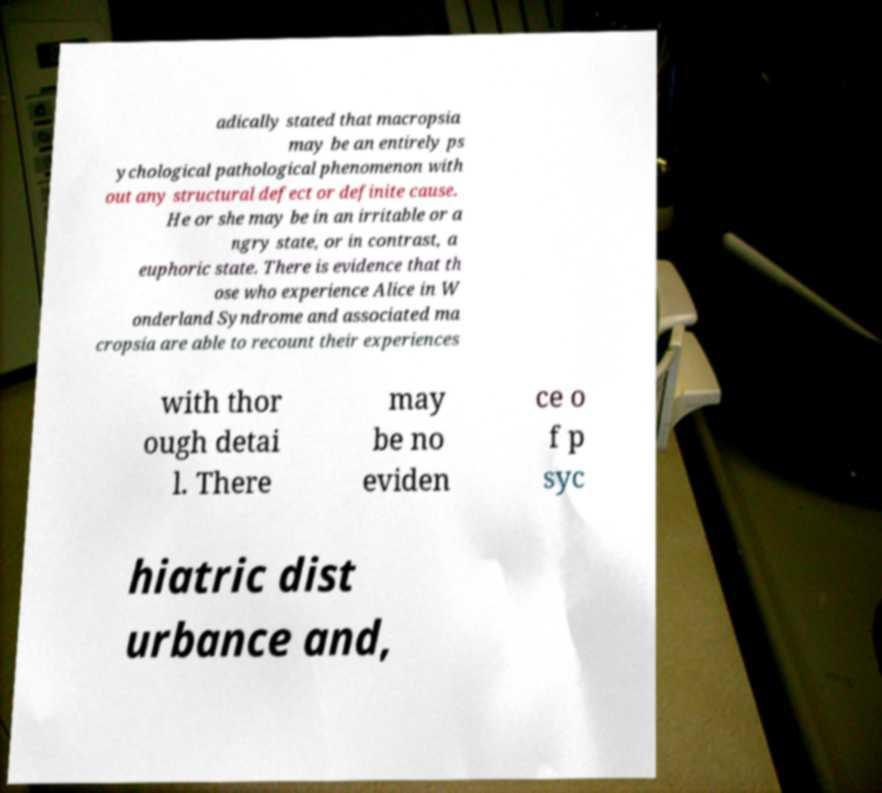Can you accurately transcribe the text from the provided image for me? adically stated that macropsia may be an entirely ps ychological pathological phenomenon with out any structural defect or definite cause. He or she may be in an irritable or a ngry state, or in contrast, a euphoric state. There is evidence that th ose who experience Alice in W onderland Syndrome and associated ma cropsia are able to recount their experiences with thor ough detai l. There may be no eviden ce o f p syc hiatric dist urbance and, 